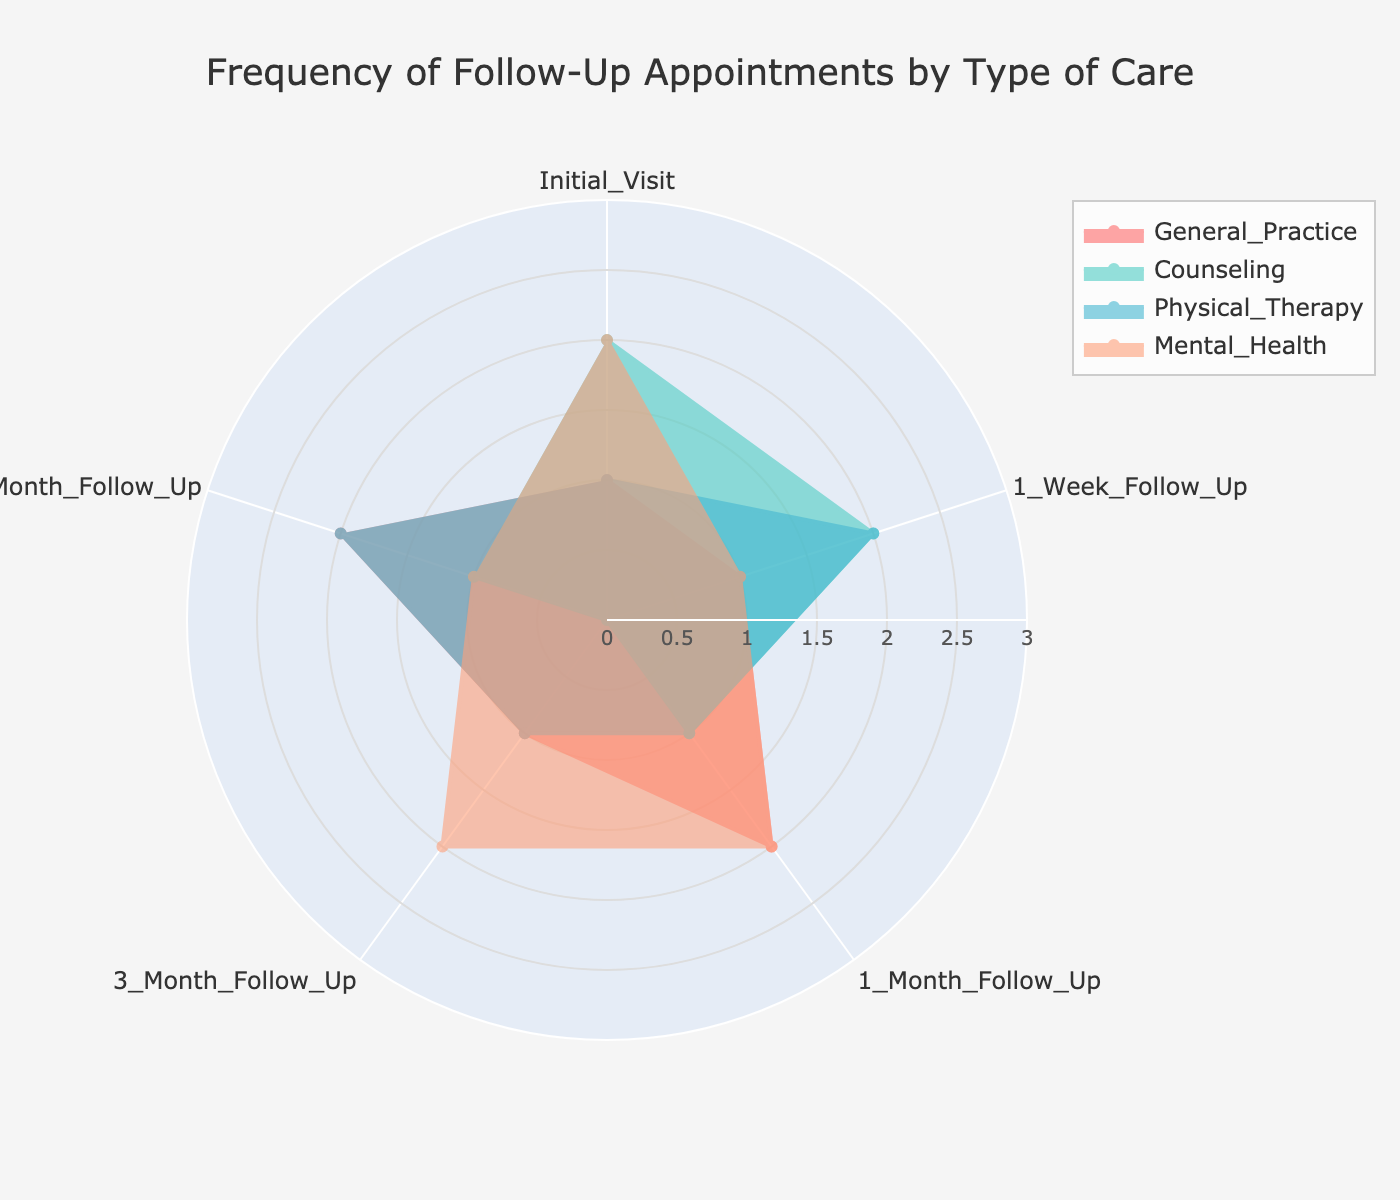What is the title of the radar chart? The title is displayed at the top of the radar chart.
Answer: Frequency of Follow-Up Appointments by Type of Care Which type of care has the highest number of follow-up appointments at the 1-Month Follow-Up stage? In the radar chart, find the 1-Month Follow-Up stage and identify the type of care with the highest value.
Answer: General Practice How many follow-up stages are represented in the radar chart? Count the number of points along the axes of the radar chart, each representing a stage.
Answer: 5 Which type of care has the most consistent follow-up frequency across all stages? For each type of care, examine the variation in values across all follow-up stages. The one with the least variation is the most consistent.
Answer: Physical Therapy What is the total number of appointments for Mental Health across all follow-up stages? Add the values for Mental Health at each follow-up stage: 2 (Initial), 1 (1-Week), 2 (1-Month), 2 (3-Month), 1 (6-Month).
Answer: 8 Which follow-up stage shows the most significant difference in frequency between General Practice and Counseling? For each follow-up stage, calculate the absolute difference between the values for General Practice and Counseling, and identify the stage with the highest difference.
Answer: 3 Month Follow-Up At which follow-up stage does General Practice have double the number of appointments compared to the 1-Week Follow-Up stage? Compare each stage's value for General Practice to twice the value at the 1-Week Follow-Up (which is 1 × 2 = 2).
Answer: 1 Month Follow-Up What is the range of values for Physical Therapy across the follow-up stages? Find the minimum and maximum values for Physical Therapy and compute the difference (range).
Answer: 1 Which type of care has an appointment frequency of zero at any follow-up stage, and what stage is it? Identify the follow-up stages with any zero values and the corresponding type of care.
Answer: Counseling, 3 Month Follow-Up Which follow-up stage has the same number of appointments for both Mental Health and Initial Visit? Compare the number of appointments for all follow-up stages, identifying any stage where both values are equal.
Answer: 1 Month Follow-Up 